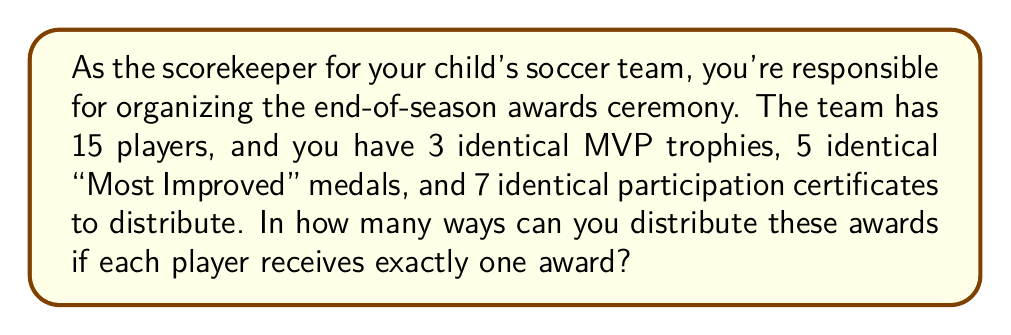Solve this math problem. Let's approach this step-by-step using the multiplication principle of counting:

1) First, we need to choose 3 players for the MVP trophies:
   This can be done in $\binom{15}{3}$ ways.

2) After that, we need to choose 5 players from the remaining 12 for the "Most Improved" medals:
   This can be done in $\binom{12}{5}$ ways.

3) The remaining 7 players will automatically receive the participation certificates.

4) By the multiplication principle, the total number of ways to distribute the awards is:

   $$\binom{15}{3} \cdot \binom{12}{5}$$

5) Let's calculate these combinations:
   
   $$\binom{15}{3} = \frac{15!}{3!(15-3)!} = \frac{15!}{3!12!} = 455$$
   
   $$\binom{12}{5} = \frac{12!}{5!(12-5)!} = \frac{12!}{5!7!} = 792$$

6) Therefore, the total number of ways is:

   $$455 \cdot 792 = 360,360$$
Answer: 360,360 